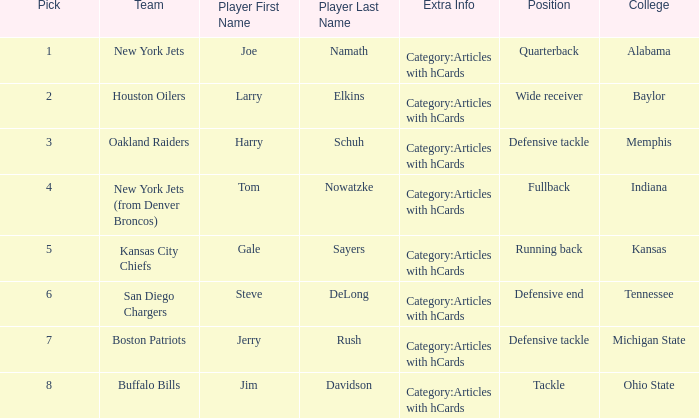Which player is from Ohio State College? Jim Davidson Category:Articles with hCards. 